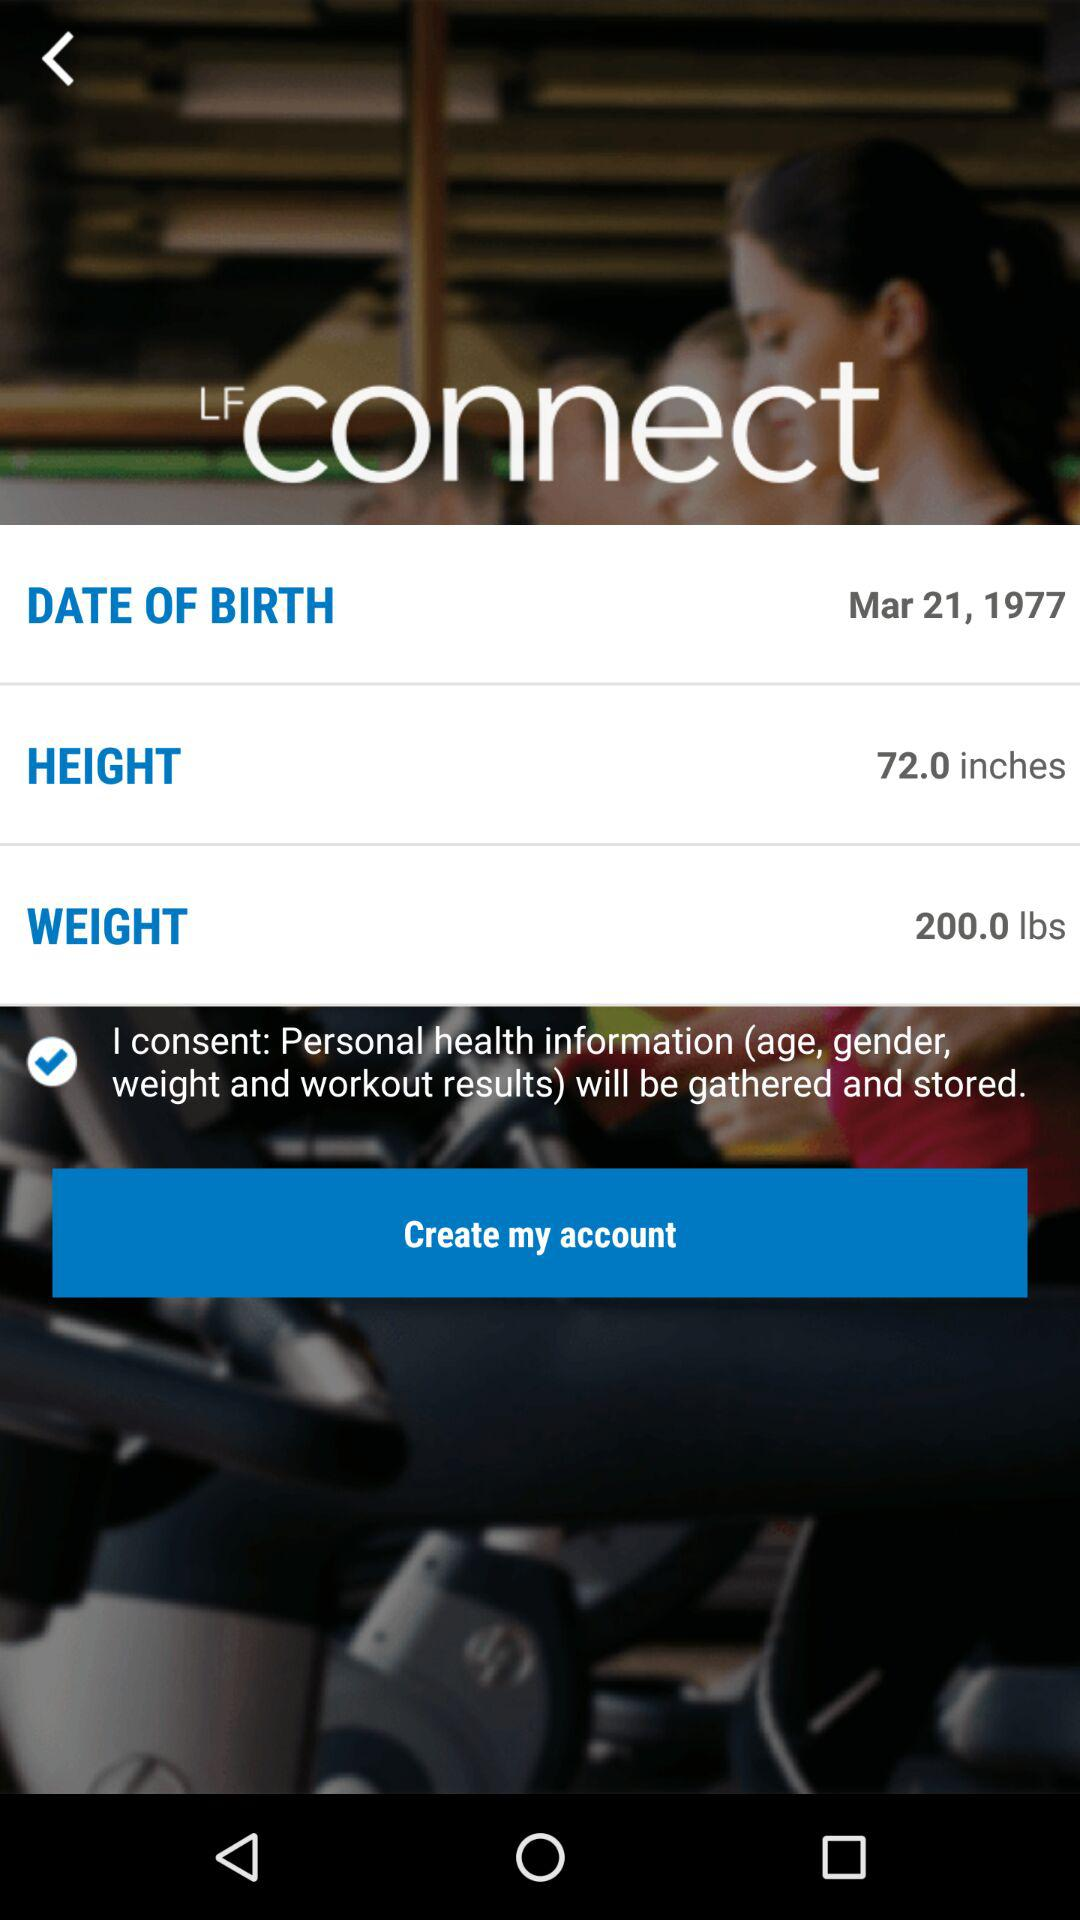What is the height? The height is 72 inches. 